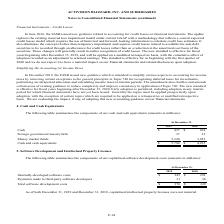According to Activision Blizzard's financial document, What was the cash amount in 2019? According to the financial document, 437 (in millions). The relevant text states: "Cash $ 437 $ 268..." Also, What was the foreign government treasure bills amount in 2019? According to the financial document, 37 (in millions). The relevant text states: "Cash $ 437 $ 268..." Also, What was the amount of cash and cash equivalents in 2018? According to the financial document, 4,225 (in millions). The relevant text states: "Cash and cash equivalents $ 5,794 $ 4,225..." Also, can you calculate: What was the change in cash between 2018 and 2019? Based on the calculation: 437-268, the result is 169 (in millions). This is based on the information: "Cash $ 437 $ 268 Cash $ 437 $ 268..." The key data points involved are: 268, 437. Also, can you calculate: What was the change in money market funds between 2018 and 2019? Based on the calculation: (5,320-3,925), the result is 1395 (in millions). This is based on the information: "Money market funds 5,320 3,925 Money market funds 5,320 3,925..." The key data points involved are: 3,925, 5,320. Also, can you calculate: What was the percentage change in cash and cash equivalents between 2018 and 2019? To answer this question, I need to perform calculations using the financial data. The calculation is: ($5,794-$4,225)/$4,225, which equals 37.14 (percentage). This is based on the information: "Cash and cash equivalents $ 5,794 $ 4,225 Cash and cash equivalents $ 5,794 $ 4,225..." The key data points involved are: 4,225, 5,794. 